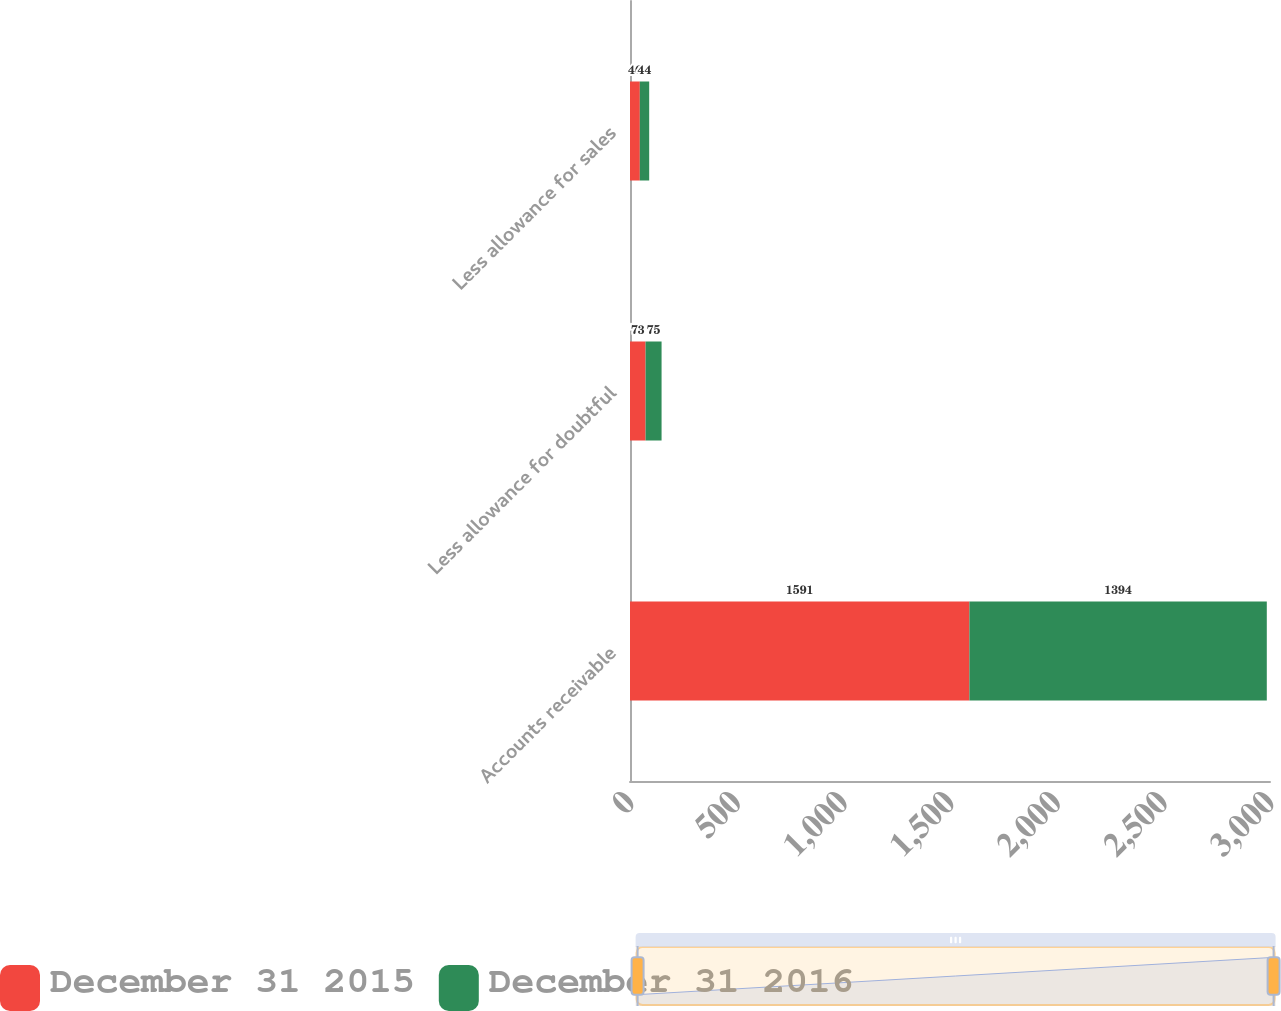Convert chart. <chart><loc_0><loc_0><loc_500><loc_500><stacked_bar_chart><ecel><fcel>Accounts receivable<fcel>Less allowance for doubtful<fcel>Less allowance for sales<nl><fcel>December 31 2015<fcel>1591<fcel>73<fcel>46<nl><fcel>December 31 2016<fcel>1394<fcel>75<fcel>44<nl></chart> 